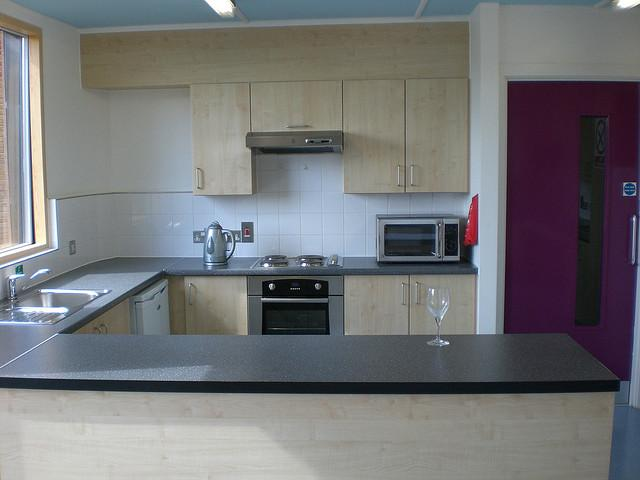What is on top of the counter?

Choices:
A) book
B) television
C) apple
D) coffee pot coffee pot 